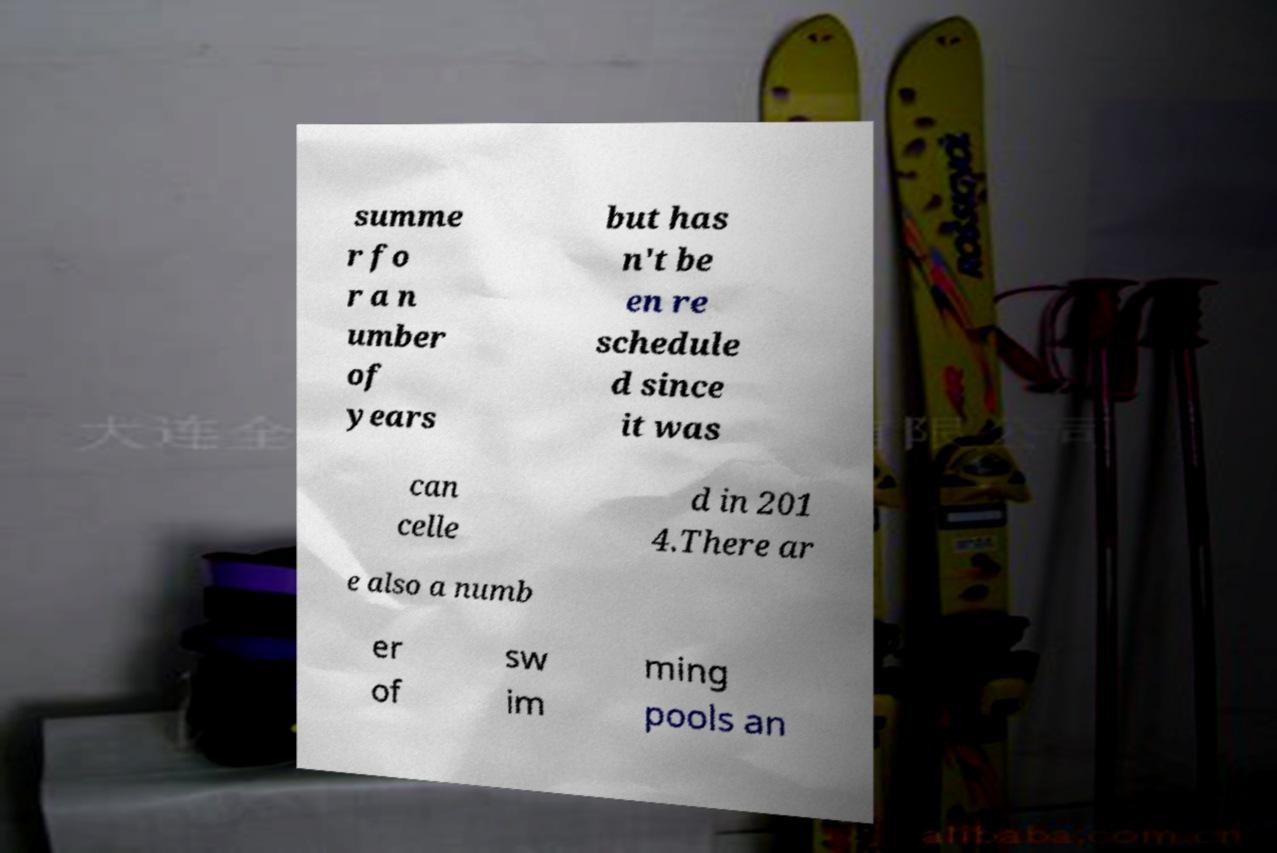I need the written content from this picture converted into text. Can you do that? summe r fo r a n umber of years but has n't be en re schedule d since it was can celle d in 201 4.There ar e also a numb er of sw im ming pools an 